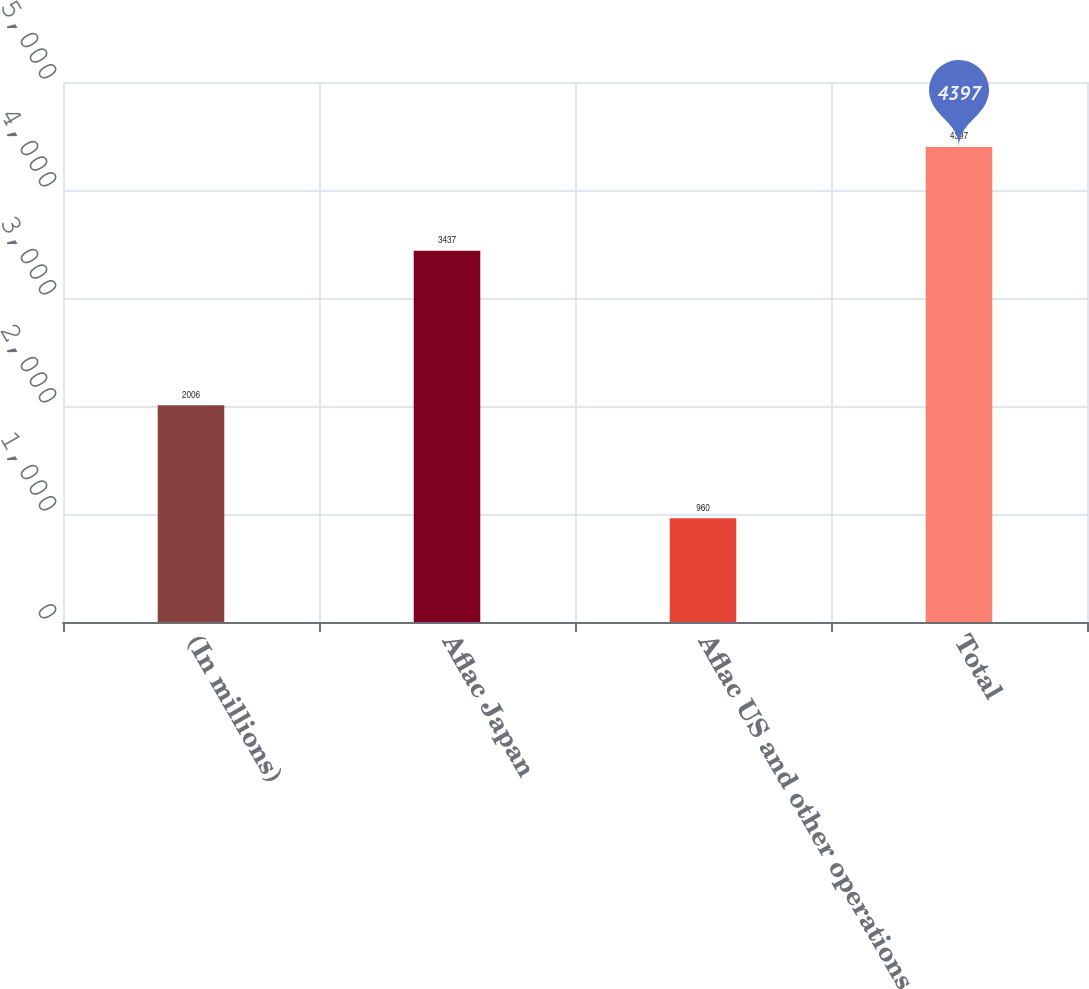<chart> <loc_0><loc_0><loc_500><loc_500><bar_chart><fcel>(In millions)<fcel>Aflac Japan<fcel>Aflac US and other operations<fcel>Total<nl><fcel>2006<fcel>3437<fcel>960<fcel>4397<nl></chart> 